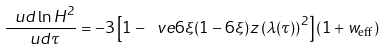Convert formula to latex. <formula><loc_0><loc_0><loc_500><loc_500>\frac { \ u d \ln { H ^ { 2 } } } { \ u d \tau } = - 3 \left [ 1 - \ v e 6 \xi ( 1 - 6 \xi ) z \left ( \lambda ( \tau ) \right ) ^ { 2 } \right ] \left ( 1 + w _ { \text {eff} } \right )</formula> 